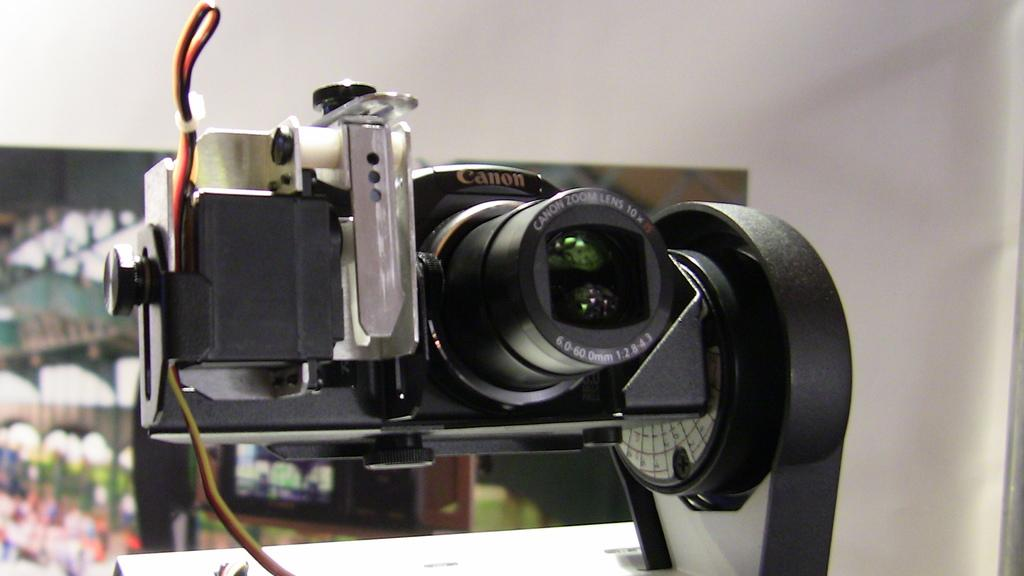What is the main subject in the center of the image? There is a camera in the center of the image. What can be seen in the background of the image? There is a wall in the background of the image. What type of cloth is draped over the camera in the image? There is no cloth draped over the camera in the image; it is simply a camera in the center of the image. 